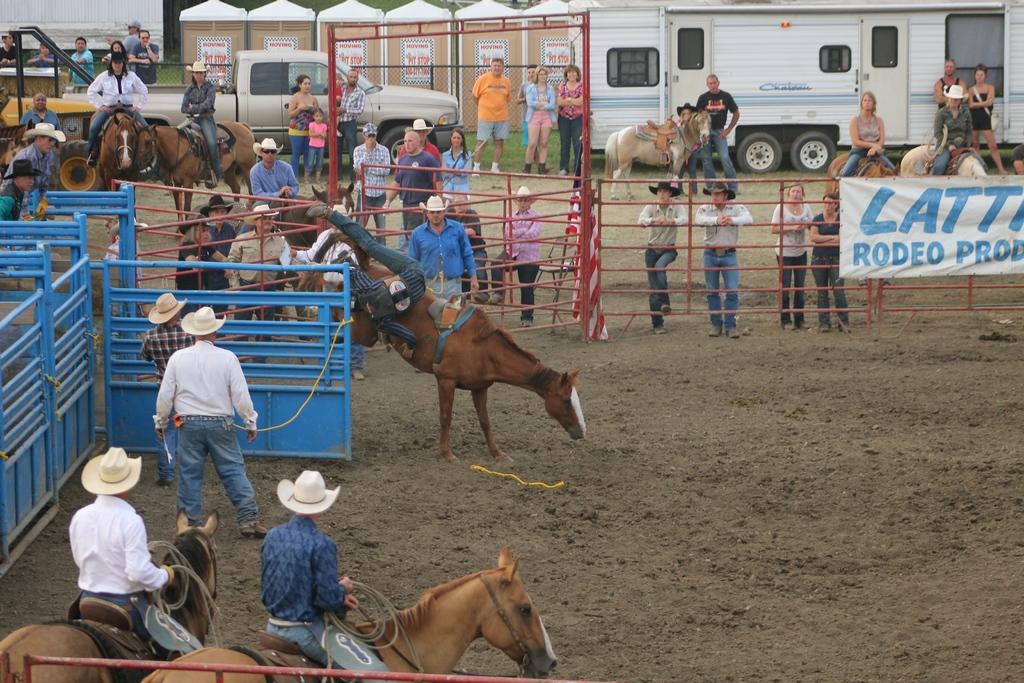Please provide a concise description of this image. Here I can see few people are riding the horses. Around these people there is a metal fencing. On the right side there is a banner attached to this fencing. On this banner there is some text. In the background there are many people standing and few people are sitting on the horses. There are few vehicles. At the top of the image there are few boards on which I can see the text. 